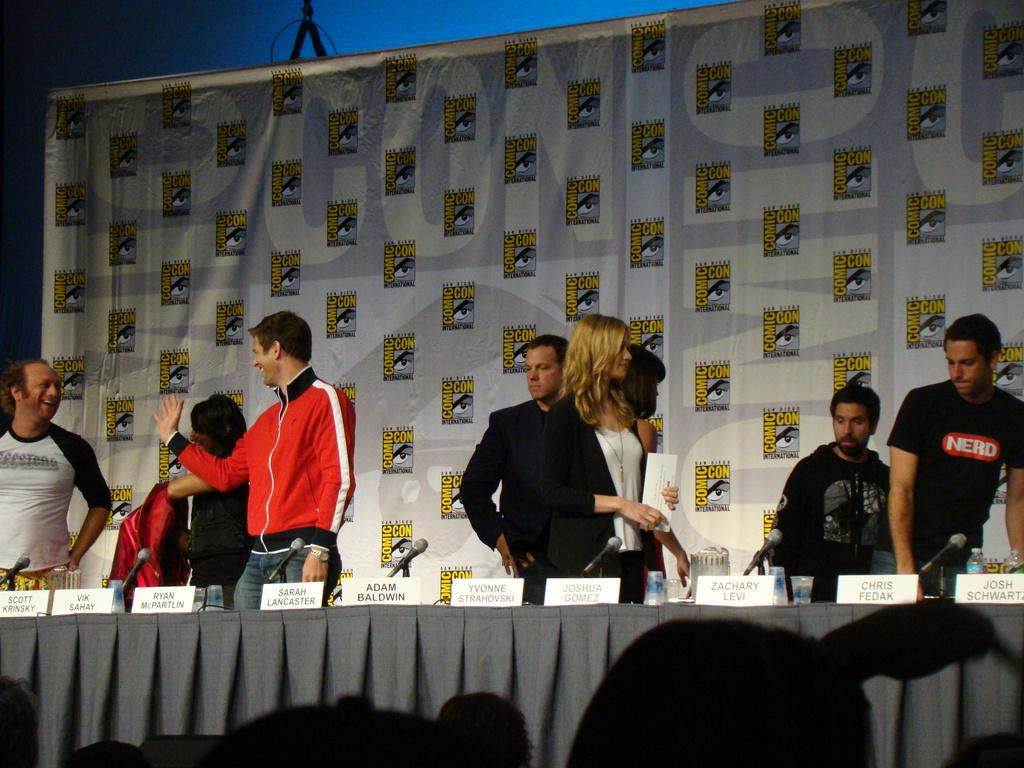How many people are in the image? There is a group of people in the image. Where are the people located in the image? The people are standing on a stage. What objects can be seen on the table in the image? There is a mic and a name board on the table. What is visible in the background of the image? There is a curtain visible in the background of the image. Are there any dinosaurs visible in the image? No, there are no dinosaurs present in the image. Can you tell me how many sea creatures are swimming in the background of the image? There is no sea or sea creatures visible in the image; it features a curtain in the background. 